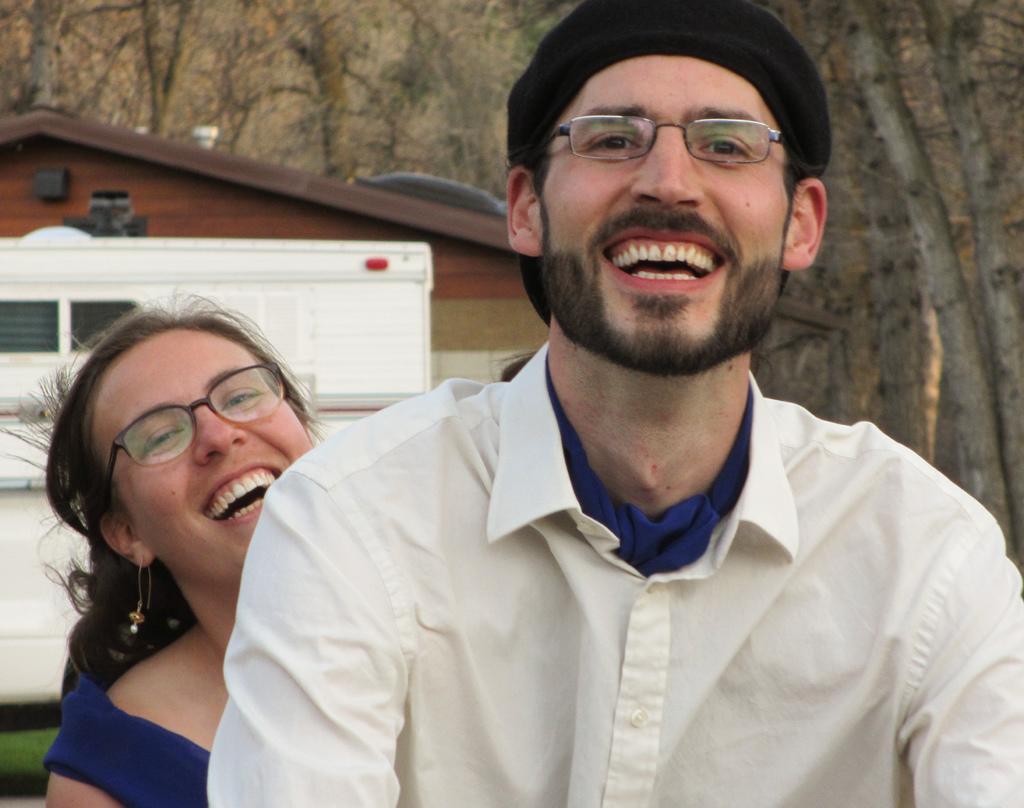Can you describe this image briefly? In this image we can see one man and woman are laughing. The man is wearing a white color shirt and woman is wearing blue color dress. Behind the wooden house and trees are there. 